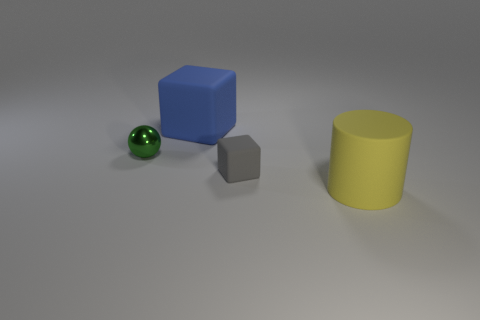Is there anything else that has the same material as the sphere?
Your response must be concise. No. The big object left of the large matte object that is in front of the big object behind the metallic thing is made of what material?
Ensure brevity in your answer.  Rubber. How many large objects are either purple metal spheres or gray things?
Your answer should be very brief. 0. What number of other things are the same size as the ball?
Provide a succinct answer. 1. Do the large matte object left of the large yellow matte thing and the small gray matte thing have the same shape?
Your response must be concise. Yes. What color is the other rubber thing that is the same shape as the gray matte thing?
Your response must be concise. Blue. Are there any other things that have the same shape as the tiny metallic object?
Your answer should be compact. No. Is the number of gray blocks that are to the left of the tiny gray rubber thing the same as the number of gray objects?
Your response must be concise. No. What number of things are left of the yellow rubber thing and in front of the shiny sphere?
Offer a terse response. 1. What size is the other rubber thing that is the same shape as the gray rubber object?
Provide a succinct answer. Large. 